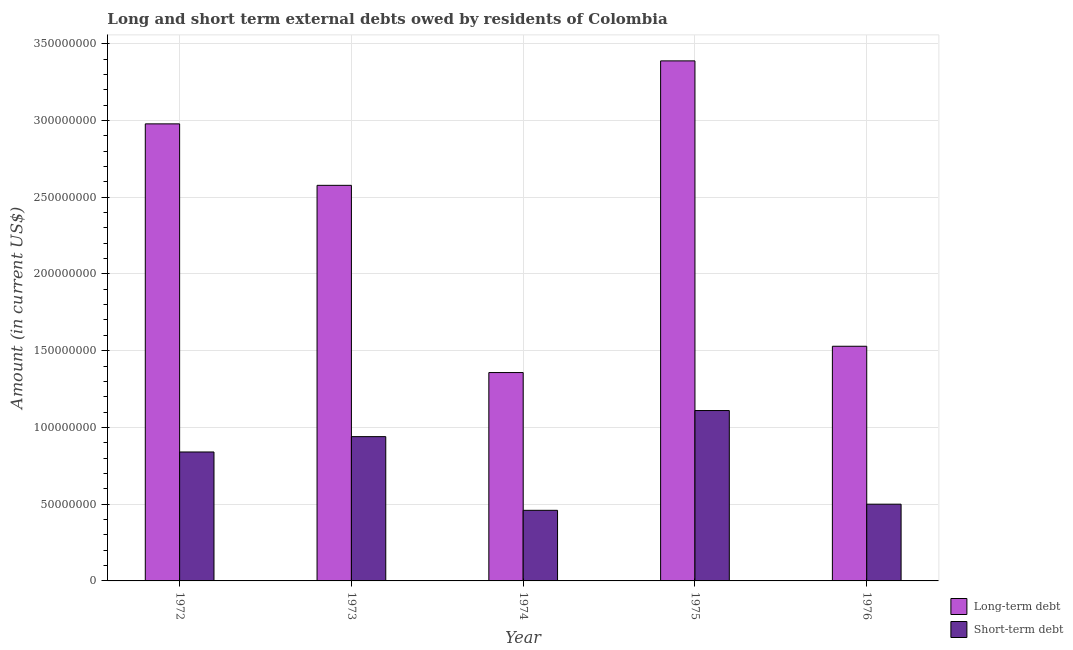Are the number of bars per tick equal to the number of legend labels?
Offer a very short reply. Yes. How many bars are there on the 2nd tick from the left?
Ensure brevity in your answer.  2. What is the label of the 3rd group of bars from the left?
Make the answer very short. 1974. What is the short-term debts owed by residents in 1974?
Ensure brevity in your answer.  4.60e+07. Across all years, what is the maximum long-term debts owed by residents?
Ensure brevity in your answer.  3.39e+08. Across all years, what is the minimum short-term debts owed by residents?
Your response must be concise. 4.60e+07. In which year was the long-term debts owed by residents maximum?
Offer a very short reply. 1975. In which year was the short-term debts owed by residents minimum?
Provide a short and direct response. 1974. What is the total long-term debts owed by residents in the graph?
Offer a very short reply. 1.18e+09. What is the difference between the long-term debts owed by residents in 1972 and that in 1975?
Your answer should be very brief. -4.10e+07. What is the difference between the long-term debts owed by residents in 1973 and the short-term debts owed by residents in 1974?
Offer a terse response. 1.22e+08. What is the average short-term debts owed by residents per year?
Keep it short and to the point. 7.70e+07. In the year 1974, what is the difference between the short-term debts owed by residents and long-term debts owed by residents?
Offer a very short reply. 0. In how many years, is the short-term debts owed by residents greater than 180000000 US$?
Your response must be concise. 0. What is the ratio of the long-term debts owed by residents in 1973 to that in 1974?
Make the answer very short. 1.9. Is the long-term debts owed by residents in 1975 less than that in 1976?
Give a very brief answer. No. What is the difference between the highest and the second highest long-term debts owed by residents?
Offer a very short reply. 4.10e+07. What is the difference between the highest and the lowest long-term debts owed by residents?
Your response must be concise. 2.03e+08. In how many years, is the short-term debts owed by residents greater than the average short-term debts owed by residents taken over all years?
Provide a succinct answer. 3. What does the 2nd bar from the left in 1973 represents?
Provide a short and direct response. Short-term debt. What does the 2nd bar from the right in 1975 represents?
Your answer should be compact. Long-term debt. What is the difference between two consecutive major ticks on the Y-axis?
Provide a succinct answer. 5.00e+07. Are the values on the major ticks of Y-axis written in scientific E-notation?
Your answer should be compact. No. How many legend labels are there?
Offer a terse response. 2. What is the title of the graph?
Provide a succinct answer. Long and short term external debts owed by residents of Colombia. What is the label or title of the X-axis?
Keep it short and to the point. Year. What is the label or title of the Y-axis?
Your answer should be compact. Amount (in current US$). What is the Amount (in current US$) of Long-term debt in 1972?
Your answer should be very brief. 2.98e+08. What is the Amount (in current US$) in Short-term debt in 1972?
Provide a short and direct response. 8.40e+07. What is the Amount (in current US$) of Long-term debt in 1973?
Make the answer very short. 2.58e+08. What is the Amount (in current US$) of Short-term debt in 1973?
Offer a very short reply. 9.40e+07. What is the Amount (in current US$) of Long-term debt in 1974?
Provide a succinct answer. 1.36e+08. What is the Amount (in current US$) of Short-term debt in 1974?
Your answer should be very brief. 4.60e+07. What is the Amount (in current US$) in Long-term debt in 1975?
Offer a very short reply. 3.39e+08. What is the Amount (in current US$) in Short-term debt in 1975?
Give a very brief answer. 1.11e+08. What is the Amount (in current US$) in Long-term debt in 1976?
Your response must be concise. 1.53e+08. Across all years, what is the maximum Amount (in current US$) in Long-term debt?
Ensure brevity in your answer.  3.39e+08. Across all years, what is the maximum Amount (in current US$) in Short-term debt?
Provide a succinct answer. 1.11e+08. Across all years, what is the minimum Amount (in current US$) of Long-term debt?
Your answer should be very brief. 1.36e+08. Across all years, what is the minimum Amount (in current US$) of Short-term debt?
Keep it short and to the point. 4.60e+07. What is the total Amount (in current US$) of Long-term debt in the graph?
Keep it short and to the point. 1.18e+09. What is the total Amount (in current US$) of Short-term debt in the graph?
Offer a very short reply. 3.85e+08. What is the difference between the Amount (in current US$) in Long-term debt in 1972 and that in 1973?
Ensure brevity in your answer.  4.00e+07. What is the difference between the Amount (in current US$) of Short-term debt in 1972 and that in 1973?
Provide a succinct answer. -1.00e+07. What is the difference between the Amount (in current US$) of Long-term debt in 1972 and that in 1974?
Your response must be concise. 1.62e+08. What is the difference between the Amount (in current US$) of Short-term debt in 1972 and that in 1974?
Keep it short and to the point. 3.80e+07. What is the difference between the Amount (in current US$) of Long-term debt in 1972 and that in 1975?
Your answer should be compact. -4.10e+07. What is the difference between the Amount (in current US$) in Short-term debt in 1972 and that in 1975?
Your answer should be compact. -2.70e+07. What is the difference between the Amount (in current US$) in Long-term debt in 1972 and that in 1976?
Keep it short and to the point. 1.45e+08. What is the difference between the Amount (in current US$) of Short-term debt in 1972 and that in 1976?
Provide a succinct answer. 3.40e+07. What is the difference between the Amount (in current US$) of Long-term debt in 1973 and that in 1974?
Offer a terse response. 1.22e+08. What is the difference between the Amount (in current US$) in Short-term debt in 1973 and that in 1974?
Your answer should be compact. 4.80e+07. What is the difference between the Amount (in current US$) of Long-term debt in 1973 and that in 1975?
Your answer should be compact. -8.11e+07. What is the difference between the Amount (in current US$) of Short-term debt in 1973 and that in 1975?
Offer a very short reply. -1.70e+07. What is the difference between the Amount (in current US$) of Long-term debt in 1973 and that in 1976?
Ensure brevity in your answer.  1.05e+08. What is the difference between the Amount (in current US$) of Short-term debt in 1973 and that in 1976?
Provide a succinct answer. 4.40e+07. What is the difference between the Amount (in current US$) in Long-term debt in 1974 and that in 1975?
Offer a terse response. -2.03e+08. What is the difference between the Amount (in current US$) of Short-term debt in 1974 and that in 1975?
Your answer should be very brief. -6.50e+07. What is the difference between the Amount (in current US$) of Long-term debt in 1974 and that in 1976?
Make the answer very short. -1.71e+07. What is the difference between the Amount (in current US$) in Long-term debt in 1975 and that in 1976?
Offer a terse response. 1.86e+08. What is the difference between the Amount (in current US$) of Short-term debt in 1975 and that in 1976?
Keep it short and to the point. 6.10e+07. What is the difference between the Amount (in current US$) in Long-term debt in 1972 and the Amount (in current US$) in Short-term debt in 1973?
Your answer should be very brief. 2.04e+08. What is the difference between the Amount (in current US$) in Long-term debt in 1972 and the Amount (in current US$) in Short-term debt in 1974?
Provide a short and direct response. 2.52e+08. What is the difference between the Amount (in current US$) in Long-term debt in 1972 and the Amount (in current US$) in Short-term debt in 1975?
Your answer should be compact. 1.87e+08. What is the difference between the Amount (in current US$) of Long-term debt in 1972 and the Amount (in current US$) of Short-term debt in 1976?
Give a very brief answer. 2.48e+08. What is the difference between the Amount (in current US$) in Long-term debt in 1973 and the Amount (in current US$) in Short-term debt in 1974?
Offer a very short reply. 2.12e+08. What is the difference between the Amount (in current US$) of Long-term debt in 1973 and the Amount (in current US$) of Short-term debt in 1975?
Keep it short and to the point. 1.47e+08. What is the difference between the Amount (in current US$) in Long-term debt in 1973 and the Amount (in current US$) in Short-term debt in 1976?
Offer a very short reply. 2.08e+08. What is the difference between the Amount (in current US$) in Long-term debt in 1974 and the Amount (in current US$) in Short-term debt in 1975?
Ensure brevity in your answer.  2.47e+07. What is the difference between the Amount (in current US$) of Long-term debt in 1974 and the Amount (in current US$) of Short-term debt in 1976?
Offer a very short reply. 8.57e+07. What is the difference between the Amount (in current US$) in Long-term debt in 1975 and the Amount (in current US$) in Short-term debt in 1976?
Ensure brevity in your answer.  2.89e+08. What is the average Amount (in current US$) in Long-term debt per year?
Your answer should be compact. 2.37e+08. What is the average Amount (in current US$) in Short-term debt per year?
Ensure brevity in your answer.  7.70e+07. In the year 1972, what is the difference between the Amount (in current US$) of Long-term debt and Amount (in current US$) of Short-term debt?
Give a very brief answer. 2.14e+08. In the year 1973, what is the difference between the Amount (in current US$) in Long-term debt and Amount (in current US$) in Short-term debt?
Keep it short and to the point. 1.64e+08. In the year 1974, what is the difference between the Amount (in current US$) of Long-term debt and Amount (in current US$) of Short-term debt?
Make the answer very short. 8.97e+07. In the year 1975, what is the difference between the Amount (in current US$) in Long-term debt and Amount (in current US$) in Short-term debt?
Keep it short and to the point. 2.28e+08. In the year 1976, what is the difference between the Amount (in current US$) of Long-term debt and Amount (in current US$) of Short-term debt?
Keep it short and to the point. 1.03e+08. What is the ratio of the Amount (in current US$) in Long-term debt in 1972 to that in 1973?
Provide a succinct answer. 1.16. What is the ratio of the Amount (in current US$) in Short-term debt in 1972 to that in 1973?
Provide a succinct answer. 0.89. What is the ratio of the Amount (in current US$) in Long-term debt in 1972 to that in 1974?
Keep it short and to the point. 2.19. What is the ratio of the Amount (in current US$) of Short-term debt in 1972 to that in 1974?
Your answer should be compact. 1.83. What is the ratio of the Amount (in current US$) of Long-term debt in 1972 to that in 1975?
Offer a very short reply. 0.88. What is the ratio of the Amount (in current US$) in Short-term debt in 1972 to that in 1975?
Ensure brevity in your answer.  0.76. What is the ratio of the Amount (in current US$) of Long-term debt in 1972 to that in 1976?
Make the answer very short. 1.95. What is the ratio of the Amount (in current US$) of Short-term debt in 1972 to that in 1976?
Offer a very short reply. 1.68. What is the ratio of the Amount (in current US$) of Long-term debt in 1973 to that in 1974?
Give a very brief answer. 1.9. What is the ratio of the Amount (in current US$) of Short-term debt in 1973 to that in 1974?
Ensure brevity in your answer.  2.04. What is the ratio of the Amount (in current US$) of Long-term debt in 1973 to that in 1975?
Your response must be concise. 0.76. What is the ratio of the Amount (in current US$) in Short-term debt in 1973 to that in 1975?
Your answer should be very brief. 0.85. What is the ratio of the Amount (in current US$) of Long-term debt in 1973 to that in 1976?
Your response must be concise. 1.69. What is the ratio of the Amount (in current US$) of Short-term debt in 1973 to that in 1976?
Offer a very short reply. 1.88. What is the ratio of the Amount (in current US$) of Long-term debt in 1974 to that in 1975?
Your answer should be compact. 0.4. What is the ratio of the Amount (in current US$) in Short-term debt in 1974 to that in 1975?
Your answer should be very brief. 0.41. What is the ratio of the Amount (in current US$) of Long-term debt in 1974 to that in 1976?
Your response must be concise. 0.89. What is the ratio of the Amount (in current US$) in Short-term debt in 1974 to that in 1976?
Provide a succinct answer. 0.92. What is the ratio of the Amount (in current US$) of Long-term debt in 1975 to that in 1976?
Offer a terse response. 2.22. What is the ratio of the Amount (in current US$) of Short-term debt in 1975 to that in 1976?
Give a very brief answer. 2.22. What is the difference between the highest and the second highest Amount (in current US$) of Long-term debt?
Provide a short and direct response. 4.10e+07. What is the difference between the highest and the second highest Amount (in current US$) in Short-term debt?
Keep it short and to the point. 1.70e+07. What is the difference between the highest and the lowest Amount (in current US$) in Long-term debt?
Make the answer very short. 2.03e+08. What is the difference between the highest and the lowest Amount (in current US$) in Short-term debt?
Ensure brevity in your answer.  6.50e+07. 